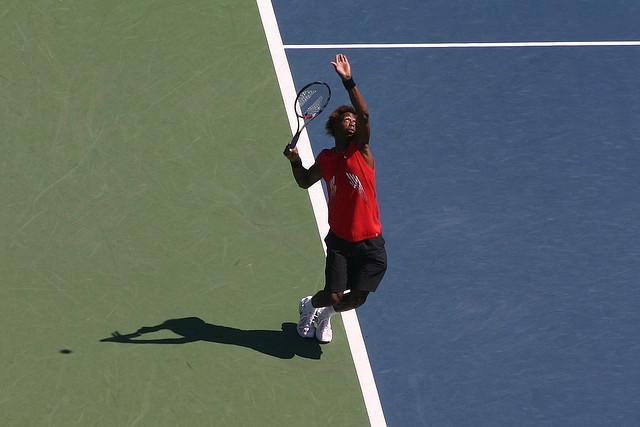How many of the chairs are blue?
Give a very brief answer. 0. 